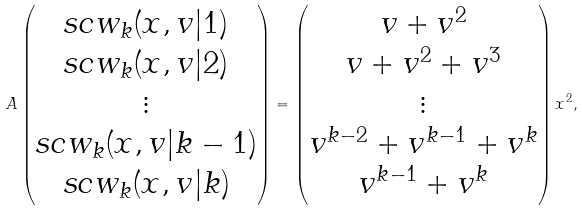<formula> <loc_0><loc_0><loc_500><loc_500>A \begin{pmatrix} s c w _ { k } ( x , v | 1 ) \\ s c w _ { k } ( x , v | 2 ) \\ \vdots \\ s c w _ { k } ( x , v | { k - 1 } ) \\ s c w _ { k } ( x , v | k ) \end{pmatrix} = \begin{pmatrix} v + v ^ { 2 } \\ v + v ^ { 2 } + v ^ { 3 } \\ \vdots \\ v ^ { k - 2 } + v ^ { k - 1 } + v ^ { k } \\ v ^ { k - 1 } + v ^ { k } \end{pmatrix} x ^ { 2 } ,</formula> 